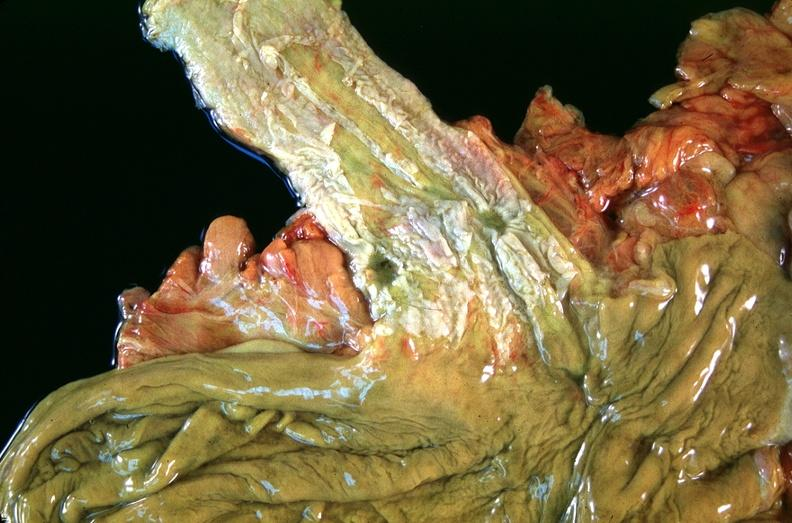does atherosclerosis show esophogus, varices due to portal hypertension from cirrhosis, hcv?
Answer the question using a single word or phrase. No 